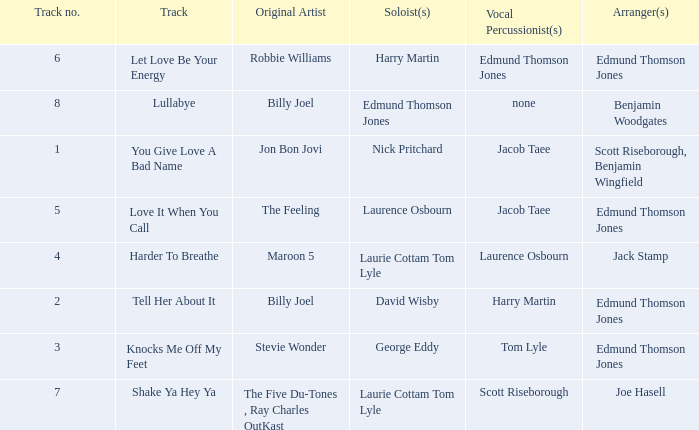Who were the original artist(s) for track number 6? Robbie Williams. 